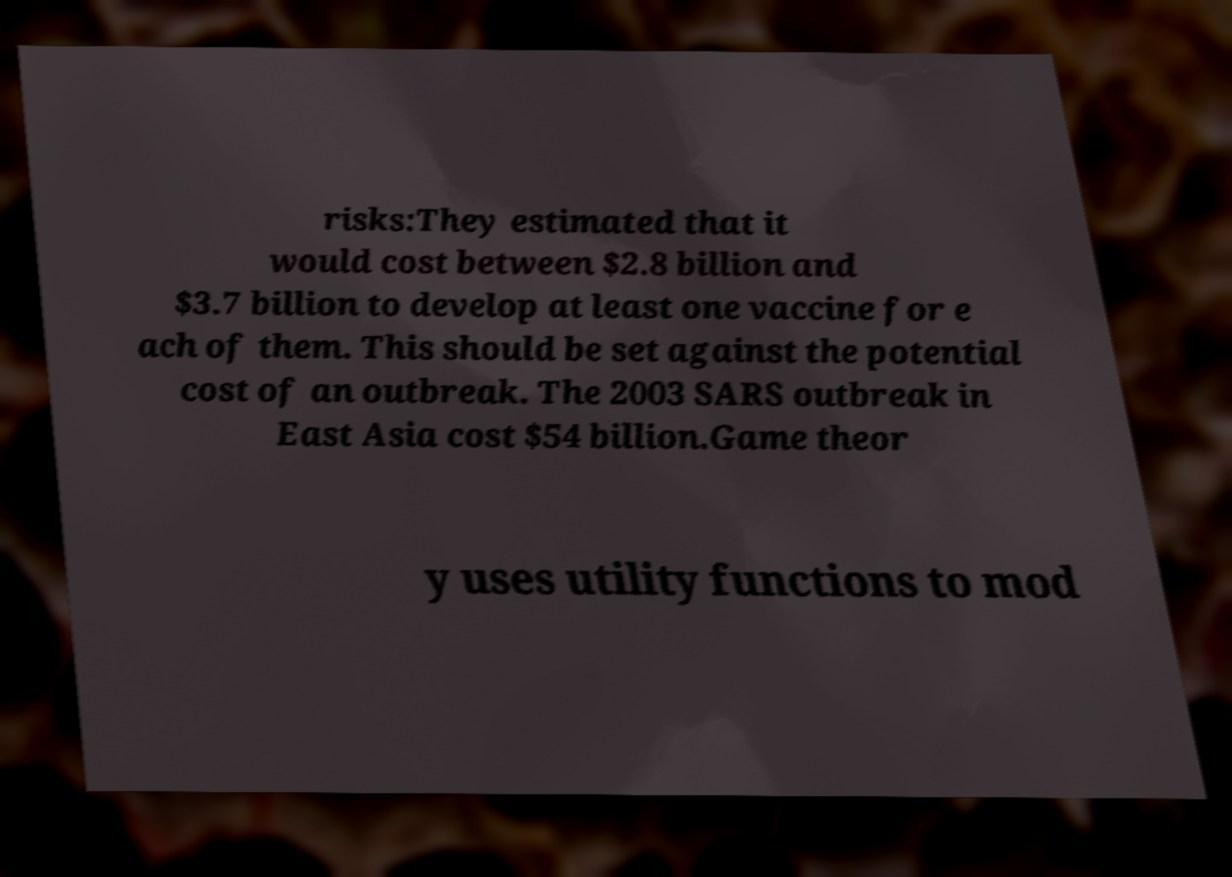Could you assist in decoding the text presented in this image and type it out clearly? risks:They estimated that it would cost between $2.8 billion and $3.7 billion to develop at least one vaccine for e ach of them. This should be set against the potential cost of an outbreak. The 2003 SARS outbreak in East Asia cost $54 billion.Game theor y uses utility functions to mod 